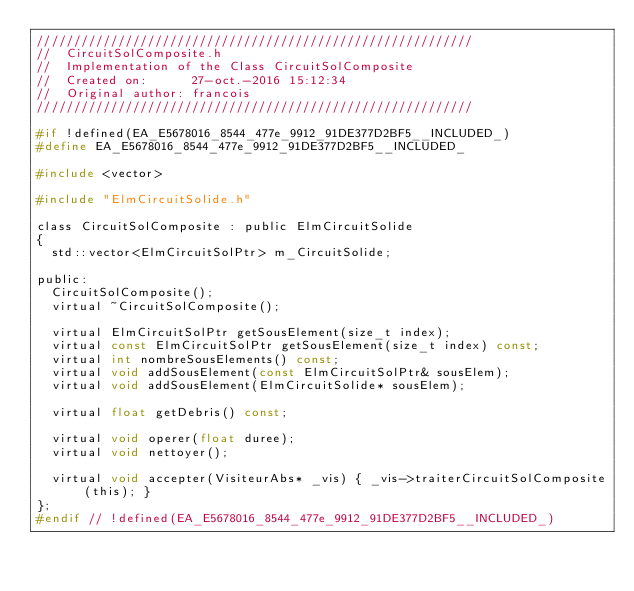Convert code to text. <code><loc_0><loc_0><loc_500><loc_500><_C_>///////////////////////////////////////////////////////////
//  CircuitSolComposite.h
//  Implementation of the Class CircuitSolComposite
//  Created on:      27-oct.-2016 15:12:34
//  Original author: francois
///////////////////////////////////////////////////////////

#if !defined(EA_E5678016_8544_477e_9912_91DE377D2BF5__INCLUDED_)
#define EA_E5678016_8544_477e_9912_91DE377D2BF5__INCLUDED_

#include <vector>

#include "ElmCircuitSolide.h"

class CircuitSolComposite : public ElmCircuitSolide
{
	std::vector<ElmCircuitSolPtr> m_CircuitSolide;

public:
	CircuitSolComposite();
	virtual ~CircuitSolComposite();
	
	virtual ElmCircuitSolPtr getSousElement(size_t index);
	virtual const ElmCircuitSolPtr getSousElement(size_t index) const;
	virtual int nombreSousElements() const;
	virtual void addSousElement(const ElmCircuitSolPtr& sousElem);
	virtual void addSousElement(ElmCircuitSolide* sousElem);

	virtual float getDebris() const;

	virtual void operer(float duree);
	virtual void nettoyer();

	virtual void accepter(VisiteurAbs* _vis) { _vis->traiterCircuitSolComposite(this); }
};
#endif // !defined(EA_E5678016_8544_477e_9912_91DE377D2BF5__INCLUDED_)
</code> 